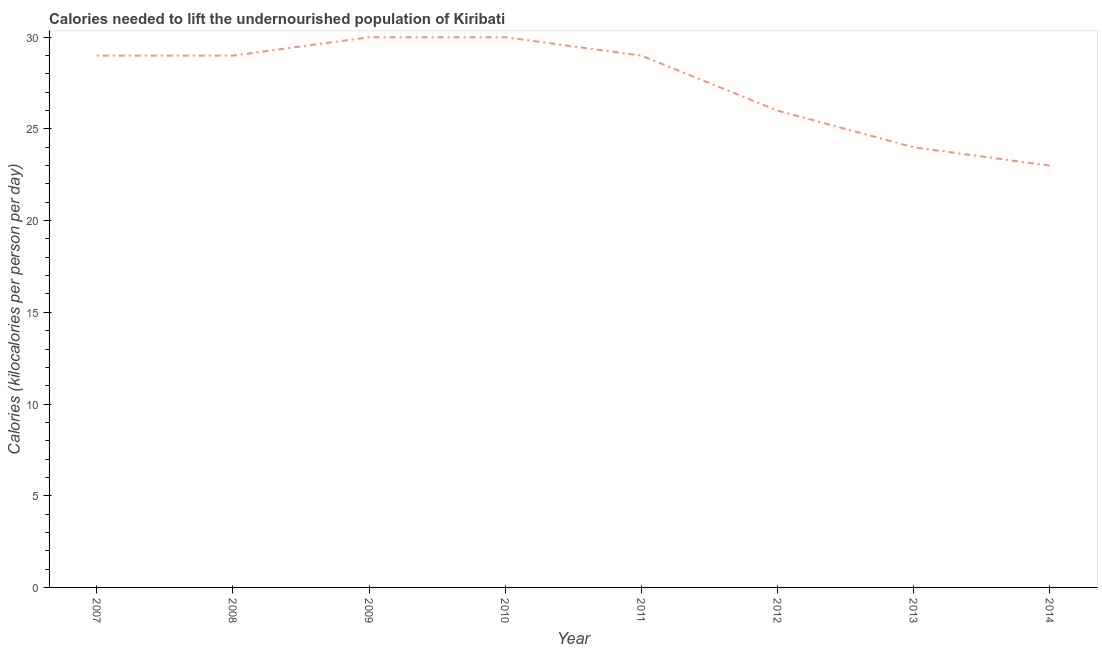What is the depth of food deficit in 2010?
Make the answer very short. 30. Across all years, what is the maximum depth of food deficit?
Your answer should be compact. 30. Across all years, what is the minimum depth of food deficit?
Provide a succinct answer. 23. In which year was the depth of food deficit minimum?
Keep it short and to the point. 2014. What is the sum of the depth of food deficit?
Your answer should be compact. 220. What is the average depth of food deficit per year?
Your answer should be compact. 27.5. In how many years, is the depth of food deficit greater than 14 kilocalories?
Your response must be concise. 8. Do a majority of the years between 2009 and 2010 (inclusive) have depth of food deficit greater than 14 kilocalories?
Your answer should be very brief. Yes. What is the ratio of the depth of food deficit in 2007 to that in 2013?
Offer a very short reply. 1.21. What is the difference between the highest and the second highest depth of food deficit?
Offer a very short reply. 0. What is the difference between the highest and the lowest depth of food deficit?
Your answer should be compact. 7. Does the depth of food deficit monotonically increase over the years?
Ensure brevity in your answer.  No. How many lines are there?
Offer a terse response. 1. How many years are there in the graph?
Give a very brief answer. 8. What is the difference between two consecutive major ticks on the Y-axis?
Offer a very short reply. 5. Are the values on the major ticks of Y-axis written in scientific E-notation?
Give a very brief answer. No. Does the graph contain grids?
Make the answer very short. No. What is the title of the graph?
Your response must be concise. Calories needed to lift the undernourished population of Kiribati. What is the label or title of the Y-axis?
Your response must be concise. Calories (kilocalories per person per day). What is the Calories (kilocalories per person per day) in 2008?
Your response must be concise. 29. What is the Calories (kilocalories per person per day) in 2009?
Your answer should be very brief. 30. What is the Calories (kilocalories per person per day) in 2010?
Give a very brief answer. 30. What is the Calories (kilocalories per person per day) in 2011?
Your response must be concise. 29. What is the Calories (kilocalories per person per day) of 2014?
Your response must be concise. 23. What is the difference between the Calories (kilocalories per person per day) in 2007 and 2008?
Offer a very short reply. 0. What is the difference between the Calories (kilocalories per person per day) in 2007 and 2010?
Ensure brevity in your answer.  -1. What is the difference between the Calories (kilocalories per person per day) in 2007 and 2012?
Make the answer very short. 3. What is the difference between the Calories (kilocalories per person per day) in 2007 and 2013?
Ensure brevity in your answer.  5. What is the difference between the Calories (kilocalories per person per day) in 2008 and 2009?
Provide a succinct answer. -1. What is the difference between the Calories (kilocalories per person per day) in 2008 and 2012?
Keep it short and to the point. 3. What is the difference between the Calories (kilocalories per person per day) in 2008 and 2014?
Provide a succinct answer. 6. What is the difference between the Calories (kilocalories per person per day) in 2009 and 2011?
Ensure brevity in your answer.  1. What is the difference between the Calories (kilocalories per person per day) in 2009 and 2013?
Offer a very short reply. 6. What is the difference between the Calories (kilocalories per person per day) in 2009 and 2014?
Your response must be concise. 7. What is the difference between the Calories (kilocalories per person per day) in 2013 and 2014?
Make the answer very short. 1. What is the ratio of the Calories (kilocalories per person per day) in 2007 to that in 2009?
Offer a very short reply. 0.97. What is the ratio of the Calories (kilocalories per person per day) in 2007 to that in 2010?
Your response must be concise. 0.97. What is the ratio of the Calories (kilocalories per person per day) in 2007 to that in 2011?
Give a very brief answer. 1. What is the ratio of the Calories (kilocalories per person per day) in 2007 to that in 2012?
Offer a terse response. 1.11. What is the ratio of the Calories (kilocalories per person per day) in 2007 to that in 2013?
Provide a short and direct response. 1.21. What is the ratio of the Calories (kilocalories per person per day) in 2007 to that in 2014?
Your answer should be compact. 1.26. What is the ratio of the Calories (kilocalories per person per day) in 2008 to that in 2009?
Provide a short and direct response. 0.97. What is the ratio of the Calories (kilocalories per person per day) in 2008 to that in 2010?
Offer a terse response. 0.97. What is the ratio of the Calories (kilocalories per person per day) in 2008 to that in 2011?
Provide a succinct answer. 1. What is the ratio of the Calories (kilocalories per person per day) in 2008 to that in 2012?
Offer a very short reply. 1.11. What is the ratio of the Calories (kilocalories per person per day) in 2008 to that in 2013?
Give a very brief answer. 1.21. What is the ratio of the Calories (kilocalories per person per day) in 2008 to that in 2014?
Offer a terse response. 1.26. What is the ratio of the Calories (kilocalories per person per day) in 2009 to that in 2010?
Your answer should be very brief. 1. What is the ratio of the Calories (kilocalories per person per day) in 2009 to that in 2011?
Your answer should be compact. 1.03. What is the ratio of the Calories (kilocalories per person per day) in 2009 to that in 2012?
Offer a terse response. 1.15. What is the ratio of the Calories (kilocalories per person per day) in 2009 to that in 2013?
Make the answer very short. 1.25. What is the ratio of the Calories (kilocalories per person per day) in 2009 to that in 2014?
Offer a very short reply. 1.3. What is the ratio of the Calories (kilocalories per person per day) in 2010 to that in 2011?
Offer a terse response. 1.03. What is the ratio of the Calories (kilocalories per person per day) in 2010 to that in 2012?
Give a very brief answer. 1.15. What is the ratio of the Calories (kilocalories per person per day) in 2010 to that in 2013?
Offer a terse response. 1.25. What is the ratio of the Calories (kilocalories per person per day) in 2010 to that in 2014?
Ensure brevity in your answer.  1.3. What is the ratio of the Calories (kilocalories per person per day) in 2011 to that in 2012?
Your answer should be very brief. 1.11. What is the ratio of the Calories (kilocalories per person per day) in 2011 to that in 2013?
Offer a terse response. 1.21. What is the ratio of the Calories (kilocalories per person per day) in 2011 to that in 2014?
Ensure brevity in your answer.  1.26. What is the ratio of the Calories (kilocalories per person per day) in 2012 to that in 2013?
Keep it short and to the point. 1.08. What is the ratio of the Calories (kilocalories per person per day) in 2012 to that in 2014?
Ensure brevity in your answer.  1.13. What is the ratio of the Calories (kilocalories per person per day) in 2013 to that in 2014?
Your response must be concise. 1.04. 